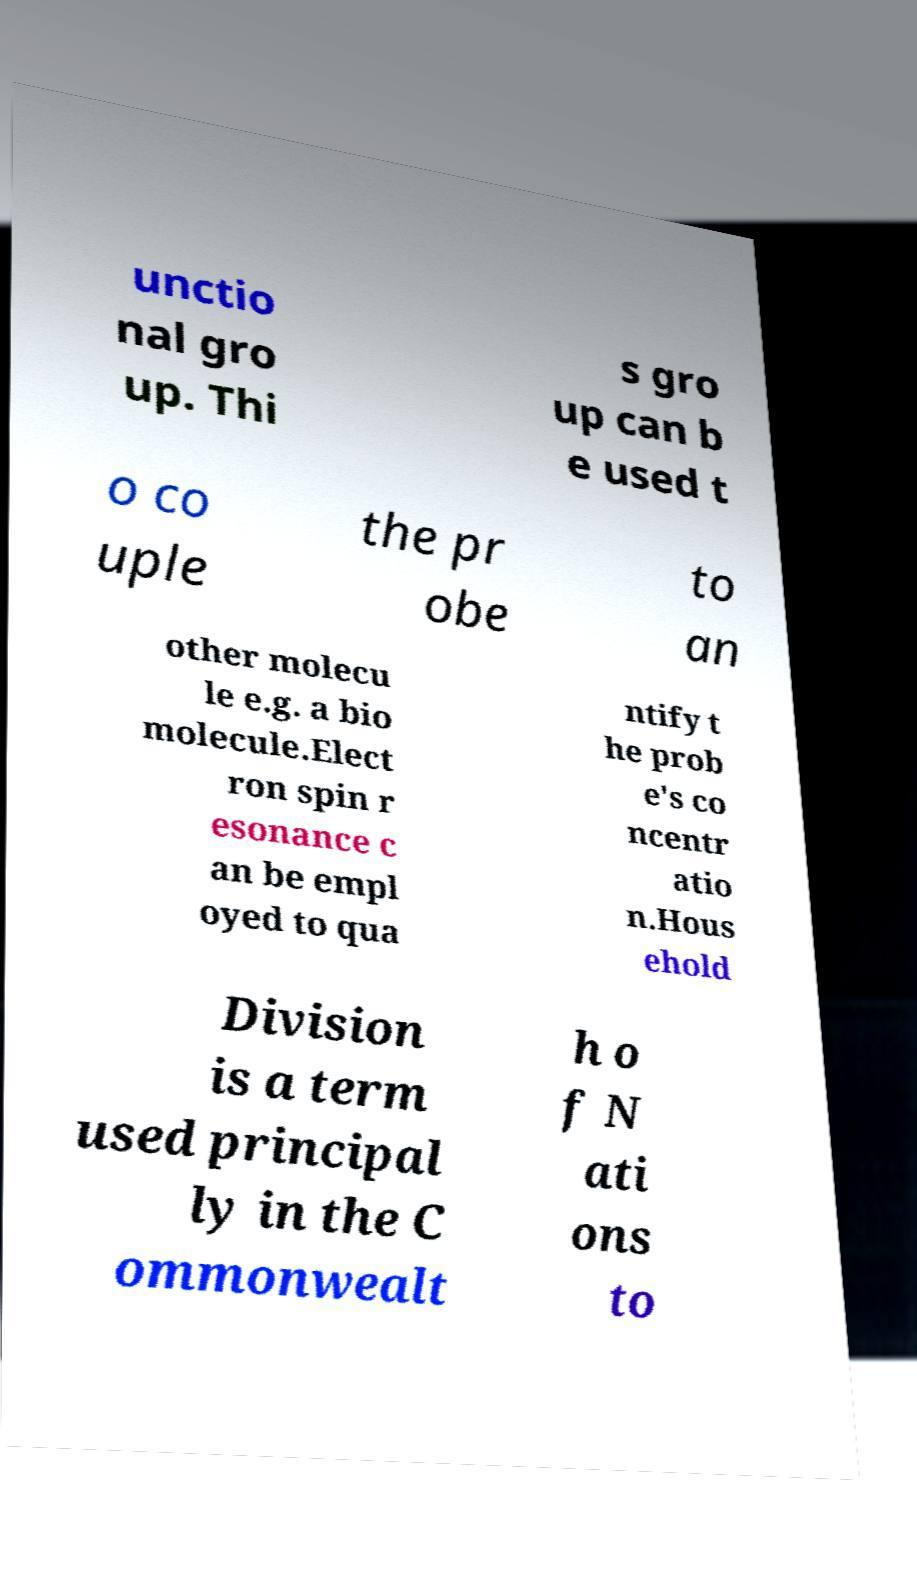Can you accurately transcribe the text from the provided image for me? unctio nal gro up. Thi s gro up can b e used t o co uple the pr obe to an other molecu le e.g. a bio molecule.Elect ron spin r esonance c an be empl oyed to qua ntify t he prob e's co ncentr atio n.Hous ehold Division is a term used principal ly in the C ommonwealt h o f N ati ons to 